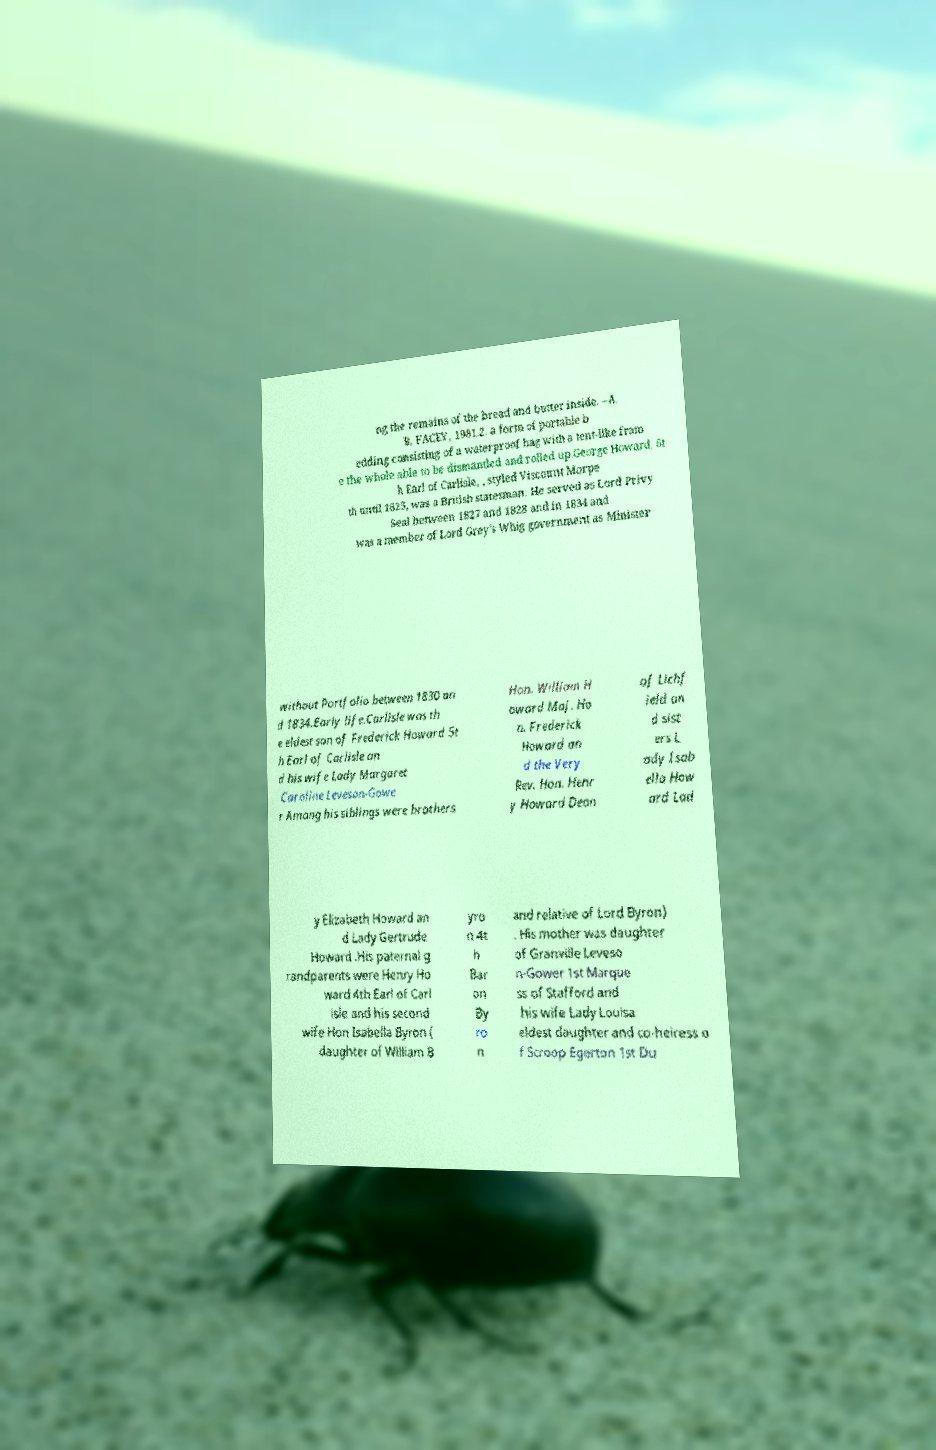What messages or text are displayed in this image? I need them in a readable, typed format. ng the remains of the bread and butter inside. –A. B. FACEY, 1981.2. a form of portable b edding consisting of a waterproof bag with a tent-like fram e the whole able to be dismantled and rolled up.George Howard, 6t h Earl of Carlisle, , styled Viscount Morpe th until 1825, was a British statesman. He served as Lord Privy Seal between 1827 and 1828 and in 1834 and was a member of Lord Grey's Whig government as Minister without Portfolio between 1830 an d 1834.Early life.Carlisle was th e eldest son of Frederick Howard 5t h Earl of Carlisle an d his wife Lady Margaret Caroline Leveson-Gowe r Among his siblings were brothers Hon. William H oward Maj. Ho n. Frederick Howard an d the Very Rev. Hon. Henr y Howard Dean of Lichf ield an d sist ers L ady Isab ella How ard Lad y Elizabeth Howard an d Lady Gertrude Howard .His paternal g randparents were Henry Ho ward 4th Earl of Carl isle and his second wife Hon Isabella Byron ( daughter of William B yro n 4t h Bar on By ro n and relative of Lord Byron) . His mother was daughter of Granville Leveso n-Gower 1st Marque ss of Stafford and his wife Lady Louisa eldest daughter and co-heiress o f Scroop Egerton 1st Du 